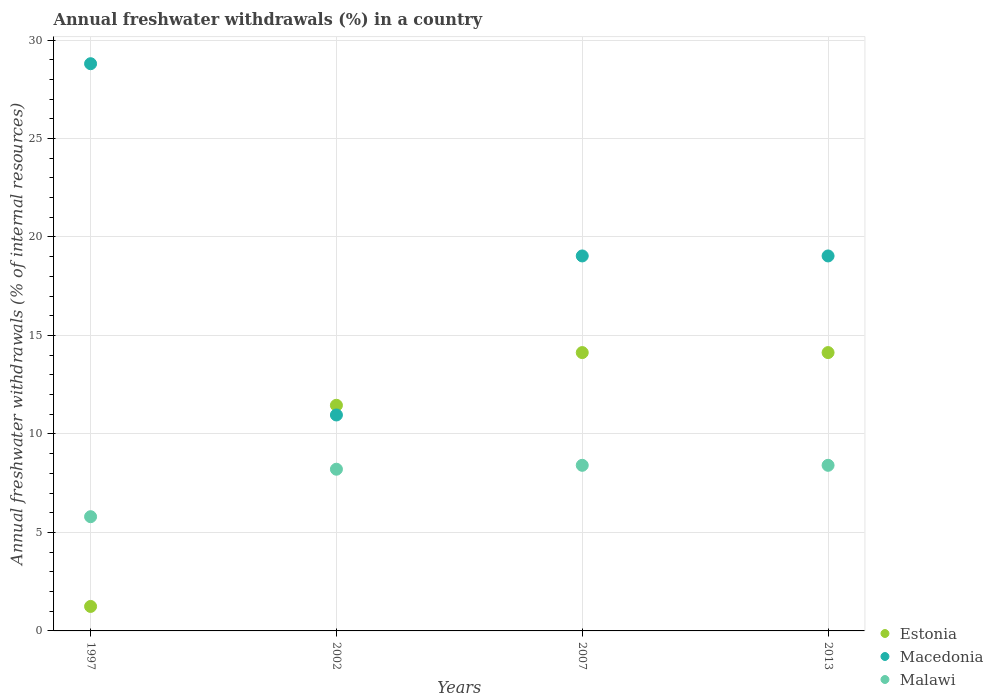How many different coloured dotlines are there?
Provide a succinct answer. 3. What is the percentage of annual freshwater withdrawals in Macedonia in 2007?
Provide a short and direct response. 19.04. Across all years, what is the maximum percentage of annual freshwater withdrawals in Malawi?
Your response must be concise. 8.41. Across all years, what is the minimum percentage of annual freshwater withdrawals in Macedonia?
Ensure brevity in your answer.  10.96. In which year was the percentage of annual freshwater withdrawals in Macedonia maximum?
Ensure brevity in your answer.  1997. In which year was the percentage of annual freshwater withdrawals in Estonia minimum?
Your response must be concise. 1997. What is the total percentage of annual freshwater withdrawals in Estonia in the graph?
Offer a very short reply. 40.96. What is the difference between the percentage of annual freshwater withdrawals in Macedonia in 1997 and that in 2002?
Offer a very short reply. 17.83. What is the difference between the percentage of annual freshwater withdrawals in Malawi in 2002 and the percentage of annual freshwater withdrawals in Estonia in 2007?
Make the answer very short. -5.92. What is the average percentage of annual freshwater withdrawals in Estonia per year?
Your response must be concise. 10.24. In the year 1997, what is the difference between the percentage of annual freshwater withdrawals in Macedonia and percentage of annual freshwater withdrawals in Estonia?
Your answer should be very brief. 27.55. What is the ratio of the percentage of annual freshwater withdrawals in Malawi in 1997 to that in 2007?
Your answer should be very brief. 0.69. Is the percentage of annual freshwater withdrawals in Malawi in 1997 less than that in 2013?
Your answer should be compact. Yes. What is the difference between the highest and the second highest percentage of annual freshwater withdrawals in Estonia?
Provide a succinct answer. 0. What is the difference between the highest and the lowest percentage of annual freshwater withdrawals in Macedonia?
Your response must be concise. 17.83. Is the sum of the percentage of annual freshwater withdrawals in Malawi in 2002 and 2013 greater than the maximum percentage of annual freshwater withdrawals in Macedonia across all years?
Your response must be concise. No. Is the percentage of annual freshwater withdrawals in Malawi strictly less than the percentage of annual freshwater withdrawals in Macedonia over the years?
Your response must be concise. Yes. How many years are there in the graph?
Keep it short and to the point. 4. Does the graph contain any zero values?
Your answer should be compact. No. How many legend labels are there?
Ensure brevity in your answer.  3. What is the title of the graph?
Keep it short and to the point. Annual freshwater withdrawals (%) in a country. Does "Latin America(developing only)" appear as one of the legend labels in the graph?
Give a very brief answer. No. What is the label or title of the Y-axis?
Make the answer very short. Annual freshwater withdrawals (% of internal resources). What is the Annual freshwater withdrawals (% of internal resources) of Estonia in 1997?
Give a very brief answer. 1.24. What is the Annual freshwater withdrawals (% of internal resources) in Macedonia in 1997?
Your answer should be very brief. 28.8. What is the Annual freshwater withdrawals (% of internal resources) in Malawi in 1997?
Keep it short and to the point. 5.8. What is the Annual freshwater withdrawals (% of internal resources) of Estonia in 2002?
Offer a terse response. 11.46. What is the Annual freshwater withdrawals (% of internal resources) of Macedonia in 2002?
Provide a short and direct response. 10.96. What is the Annual freshwater withdrawals (% of internal resources) of Malawi in 2002?
Provide a short and direct response. 8.21. What is the Annual freshwater withdrawals (% of internal resources) in Estonia in 2007?
Your response must be concise. 14.13. What is the Annual freshwater withdrawals (% of internal resources) of Macedonia in 2007?
Give a very brief answer. 19.04. What is the Annual freshwater withdrawals (% of internal resources) of Malawi in 2007?
Your response must be concise. 8.41. What is the Annual freshwater withdrawals (% of internal resources) in Estonia in 2013?
Ensure brevity in your answer.  14.13. What is the Annual freshwater withdrawals (% of internal resources) of Macedonia in 2013?
Offer a terse response. 19.04. What is the Annual freshwater withdrawals (% of internal resources) in Malawi in 2013?
Provide a short and direct response. 8.41. Across all years, what is the maximum Annual freshwater withdrawals (% of internal resources) of Estonia?
Offer a terse response. 14.13. Across all years, what is the maximum Annual freshwater withdrawals (% of internal resources) in Macedonia?
Make the answer very short. 28.8. Across all years, what is the maximum Annual freshwater withdrawals (% of internal resources) of Malawi?
Provide a short and direct response. 8.41. Across all years, what is the minimum Annual freshwater withdrawals (% of internal resources) of Estonia?
Your response must be concise. 1.24. Across all years, what is the minimum Annual freshwater withdrawals (% of internal resources) in Macedonia?
Your answer should be compact. 10.96. Across all years, what is the minimum Annual freshwater withdrawals (% of internal resources) of Malawi?
Provide a succinct answer. 5.8. What is the total Annual freshwater withdrawals (% of internal resources) of Estonia in the graph?
Offer a terse response. 40.96. What is the total Annual freshwater withdrawals (% of internal resources) of Macedonia in the graph?
Your answer should be compact. 77.83. What is the total Annual freshwater withdrawals (% of internal resources) of Malawi in the graph?
Your answer should be compact. 30.82. What is the difference between the Annual freshwater withdrawals (% of internal resources) of Estonia in 1997 and that in 2002?
Keep it short and to the point. -10.21. What is the difference between the Annual freshwater withdrawals (% of internal resources) of Macedonia in 1997 and that in 2002?
Make the answer very short. 17.83. What is the difference between the Annual freshwater withdrawals (% of internal resources) of Malawi in 1997 and that in 2002?
Provide a succinct answer. -2.41. What is the difference between the Annual freshwater withdrawals (% of internal resources) of Estonia in 1997 and that in 2007?
Your answer should be very brief. -12.89. What is the difference between the Annual freshwater withdrawals (% of internal resources) of Macedonia in 1997 and that in 2007?
Your answer should be very brief. 9.76. What is the difference between the Annual freshwater withdrawals (% of internal resources) in Malawi in 1997 and that in 2007?
Keep it short and to the point. -2.61. What is the difference between the Annual freshwater withdrawals (% of internal resources) in Estonia in 1997 and that in 2013?
Your answer should be compact. -12.89. What is the difference between the Annual freshwater withdrawals (% of internal resources) of Macedonia in 1997 and that in 2013?
Your answer should be compact. 9.76. What is the difference between the Annual freshwater withdrawals (% of internal resources) of Malawi in 1997 and that in 2013?
Offer a terse response. -2.61. What is the difference between the Annual freshwater withdrawals (% of internal resources) in Estonia in 2002 and that in 2007?
Ensure brevity in your answer.  -2.68. What is the difference between the Annual freshwater withdrawals (% of internal resources) of Macedonia in 2002 and that in 2007?
Offer a terse response. -8.07. What is the difference between the Annual freshwater withdrawals (% of internal resources) of Malawi in 2002 and that in 2007?
Give a very brief answer. -0.2. What is the difference between the Annual freshwater withdrawals (% of internal resources) of Estonia in 2002 and that in 2013?
Make the answer very short. -2.68. What is the difference between the Annual freshwater withdrawals (% of internal resources) of Macedonia in 2002 and that in 2013?
Provide a succinct answer. -8.07. What is the difference between the Annual freshwater withdrawals (% of internal resources) in Malawi in 2002 and that in 2013?
Keep it short and to the point. -0.2. What is the difference between the Annual freshwater withdrawals (% of internal resources) in Estonia in 2007 and that in 2013?
Give a very brief answer. 0. What is the difference between the Annual freshwater withdrawals (% of internal resources) of Estonia in 1997 and the Annual freshwater withdrawals (% of internal resources) of Macedonia in 2002?
Your response must be concise. -9.72. What is the difference between the Annual freshwater withdrawals (% of internal resources) of Estonia in 1997 and the Annual freshwater withdrawals (% of internal resources) of Malawi in 2002?
Make the answer very short. -6.97. What is the difference between the Annual freshwater withdrawals (% of internal resources) in Macedonia in 1997 and the Annual freshwater withdrawals (% of internal resources) in Malawi in 2002?
Ensure brevity in your answer.  20.59. What is the difference between the Annual freshwater withdrawals (% of internal resources) in Estonia in 1997 and the Annual freshwater withdrawals (% of internal resources) in Macedonia in 2007?
Make the answer very short. -17.79. What is the difference between the Annual freshwater withdrawals (% of internal resources) of Estonia in 1997 and the Annual freshwater withdrawals (% of internal resources) of Malawi in 2007?
Your answer should be very brief. -7.16. What is the difference between the Annual freshwater withdrawals (% of internal resources) in Macedonia in 1997 and the Annual freshwater withdrawals (% of internal resources) in Malawi in 2007?
Offer a terse response. 20.39. What is the difference between the Annual freshwater withdrawals (% of internal resources) of Estonia in 1997 and the Annual freshwater withdrawals (% of internal resources) of Macedonia in 2013?
Provide a short and direct response. -17.79. What is the difference between the Annual freshwater withdrawals (% of internal resources) of Estonia in 1997 and the Annual freshwater withdrawals (% of internal resources) of Malawi in 2013?
Your answer should be very brief. -7.16. What is the difference between the Annual freshwater withdrawals (% of internal resources) in Macedonia in 1997 and the Annual freshwater withdrawals (% of internal resources) in Malawi in 2013?
Offer a terse response. 20.39. What is the difference between the Annual freshwater withdrawals (% of internal resources) in Estonia in 2002 and the Annual freshwater withdrawals (% of internal resources) in Macedonia in 2007?
Offer a terse response. -7.58. What is the difference between the Annual freshwater withdrawals (% of internal resources) of Estonia in 2002 and the Annual freshwater withdrawals (% of internal resources) of Malawi in 2007?
Ensure brevity in your answer.  3.05. What is the difference between the Annual freshwater withdrawals (% of internal resources) in Macedonia in 2002 and the Annual freshwater withdrawals (% of internal resources) in Malawi in 2007?
Make the answer very short. 2.56. What is the difference between the Annual freshwater withdrawals (% of internal resources) of Estonia in 2002 and the Annual freshwater withdrawals (% of internal resources) of Macedonia in 2013?
Ensure brevity in your answer.  -7.58. What is the difference between the Annual freshwater withdrawals (% of internal resources) of Estonia in 2002 and the Annual freshwater withdrawals (% of internal resources) of Malawi in 2013?
Your answer should be compact. 3.05. What is the difference between the Annual freshwater withdrawals (% of internal resources) in Macedonia in 2002 and the Annual freshwater withdrawals (% of internal resources) in Malawi in 2013?
Your answer should be very brief. 2.56. What is the difference between the Annual freshwater withdrawals (% of internal resources) of Estonia in 2007 and the Annual freshwater withdrawals (% of internal resources) of Macedonia in 2013?
Provide a succinct answer. -4.91. What is the difference between the Annual freshwater withdrawals (% of internal resources) of Estonia in 2007 and the Annual freshwater withdrawals (% of internal resources) of Malawi in 2013?
Your answer should be very brief. 5.72. What is the difference between the Annual freshwater withdrawals (% of internal resources) of Macedonia in 2007 and the Annual freshwater withdrawals (% of internal resources) of Malawi in 2013?
Offer a very short reply. 10.63. What is the average Annual freshwater withdrawals (% of internal resources) of Estonia per year?
Ensure brevity in your answer.  10.24. What is the average Annual freshwater withdrawals (% of internal resources) in Macedonia per year?
Give a very brief answer. 19.46. What is the average Annual freshwater withdrawals (% of internal resources) in Malawi per year?
Offer a terse response. 7.71. In the year 1997, what is the difference between the Annual freshwater withdrawals (% of internal resources) of Estonia and Annual freshwater withdrawals (% of internal resources) of Macedonia?
Give a very brief answer. -27.55. In the year 1997, what is the difference between the Annual freshwater withdrawals (% of internal resources) of Estonia and Annual freshwater withdrawals (% of internal resources) of Malawi?
Offer a very short reply. -4.56. In the year 1997, what is the difference between the Annual freshwater withdrawals (% of internal resources) in Macedonia and Annual freshwater withdrawals (% of internal resources) in Malawi?
Your response must be concise. 23. In the year 2002, what is the difference between the Annual freshwater withdrawals (% of internal resources) in Estonia and Annual freshwater withdrawals (% of internal resources) in Macedonia?
Keep it short and to the point. 0.49. In the year 2002, what is the difference between the Annual freshwater withdrawals (% of internal resources) of Estonia and Annual freshwater withdrawals (% of internal resources) of Malawi?
Your answer should be very brief. 3.25. In the year 2002, what is the difference between the Annual freshwater withdrawals (% of internal resources) in Macedonia and Annual freshwater withdrawals (% of internal resources) in Malawi?
Your answer should be compact. 2.75. In the year 2007, what is the difference between the Annual freshwater withdrawals (% of internal resources) of Estonia and Annual freshwater withdrawals (% of internal resources) of Macedonia?
Provide a succinct answer. -4.91. In the year 2007, what is the difference between the Annual freshwater withdrawals (% of internal resources) in Estonia and Annual freshwater withdrawals (% of internal resources) in Malawi?
Give a very brief answer. 5.72. In the year 2007, what is the difference between the Annual freshwater withdrawals (% of internal resources) of Macedonia and Annual freshwater withdrawals (% of internal resources) of Malawi?
Ensure brevity in your answer.  10.63. In the year 2013, what is the difference between the Annual freshwater withdrawals (% of internal resources) of Estonia and Annual freshwater withdrawals (% of internal resources) of Macedonia?
Your response must be concise. -4.91. In the year 2013, what is the difference between the Annual freshwater withdrawals (% of internal resources) of Estonia and Annual freshwater withdrawals (% of internal resources) of Malawi?
Offer a very short reply. 5.72. In the year 2013, what is the difference between the Annual freshwater withdrawals (% of internal resources) of Macedonia and Annual freshwater withdrawals (% of internal resources) of Malawi?
Offer a terse response. 10.63. What is the ratio of the Annual freshwater withdrawals (% of internal resources) in Estonia in 1997 to that in 2002?
Your answer should be compact. 0.11. What is the ratio of the Annual freshwater withdrawals (% of internal resources) in Macedonia in 1997 to that in 2002?
Give a very brief answer. 2.63. What is the ratio of the Annual freshwater withdrawals (% of internal resources) of Malawi in 1997 to that in 2002?
Offer a very short reply. 0.71. What is the ratio of the Annual freshwater withdrawals (% of internal resources) in Estonia in 1997 to that in 2007?
Offer a terse response. 0.09. What is the ratio of the Annual freshwater withdrawals (% of internal resources) in Macedonia in 1997 to that in 2007?
Offer a very short reply. 1.51. What is the ratio of the Annual freshwater withdrawals (% of internal resources) in Malawi in 1997 to that in 2007?
Make the answer very short. 0.69. What is the ratio of the Annual freshwater withdrawals (% of internal resources) of Estonia in 1997 to that in 2013?
Offer a terse response. 0.09. What is the ratio of the Annual freshwater withdrawals (% of internal resources) in Macedonia in 1997 to that in 2013?
Your response must be concise. 1.51. What is the ratio of the Annual freshwater withdrawals (% of internal resources) in Malawi in 1997 to that in 2013?
Offer a terse response. 0.69. What is the ratio of the Annual freshwater withdrawals (% of internal resources) in Estonia in 2002 to that in 2007?
Keep it short and to the point. 0.81. What is the ratio of the Annual freshwater withdrawals (% of internal resources) in Macedonia in 2002 to that in 2007?
Provide a short and direct response. 0.58. What is the ratio of the Annual freshwater withdrawals (% of internal resources) of Malawi in 2002 to that in 2007?
Offer a very short reply. 0.98. What is the ratio of the Annual freshwater withdrawals (% of internal resources) of Estonia in 2002 to that in 2013?
Provide a short and direct response. 0.81. What is the ratio of the Annual freshwater withdrawals (% of internal resources) in Macedonia in 2002 to that in 2013?
Your response must be concise. 0.58. What is the ratio of the Annual freshwater withdrawals (% of internal resources) in Malawi in 2002 to that in 2013?
Give a very brief answer. 0.98. What is the ratio of the Annual freshwater withdrawals (% of internal resources) in Estonia in 2007 to that in 2013?
Offer a terse response. 1. What is the ratio of the Annual freshwater withdrawals (% of internal resources) in Macedonia in 2007 to that in 2013?
Provide a short and direct response. 1. What is the ratio of the Annual freshwater withdrawals (% of internal resources) of Malawi in 2007 to that in 2013?
Your response must be concise. 1. What is the difference between the highest and the second highest Annual freshwater withdrawals (% of internal resources) of Macedonia?
Make the answer very short. 9.76. What is the difference between the highest and the second highest Annual freshwater withdrawals (% of internal resources) in Malawi?
Your response must be concise. 0. What is the difference between the highest and the lowest Annual freshwater withdrawals (% of internal resources) in Estonia?
Provide a short and direct response. 12.89. What is the difference between the highest and the lowest Annual freshwater withdrawals (% of internal resources) in Macedonia?
Keep it short and to the point. 17.83. What is the difference between the highest and the lowest Annual freshwater withdrawals (% of internal resources) in Malawi?
Keep it short and to the point. 2.61. 